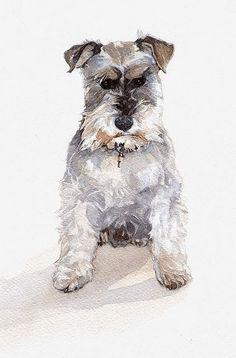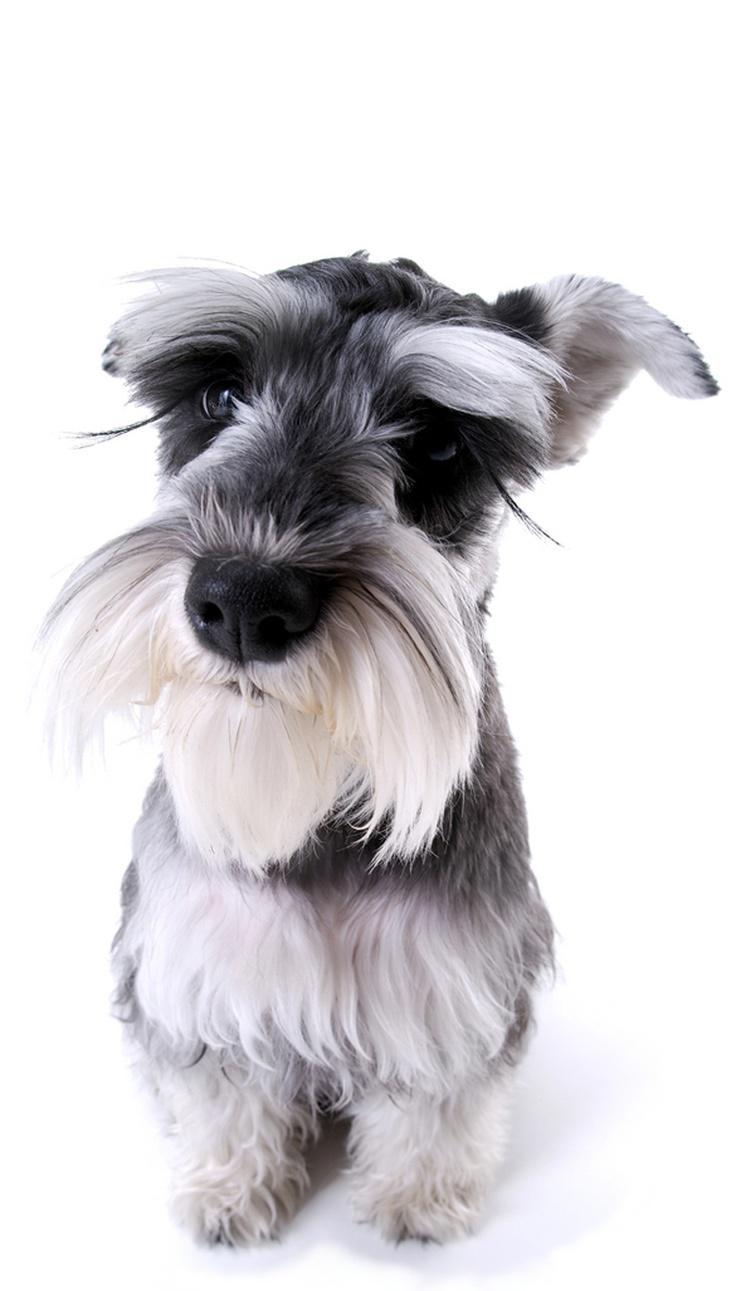The first image is the image on the left, the second image is the image on the right. Given the left and right images, does the statement "There are two dogs sitting down" hold true? Answer yes or no. Yes. 